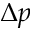<formula> <loc_0><loc_0><loc_500><loc_500>\Delta p</formula> 